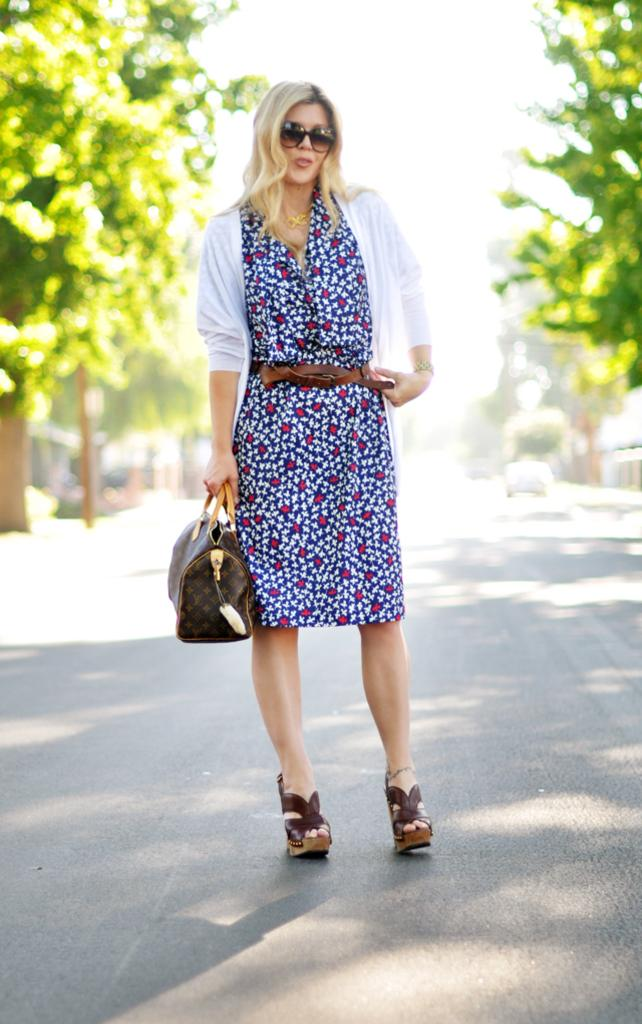Who is present in the image? There is a woman in the image. What is the woman holding in the image? The woman is holding a bag. What is the woman wearing in the image? The woman is wearing a vest. What is the color or style of the woman's hair in the image? The woman has blond hair. Where is the woman standing in the image? The woman is standing on a road. What can be seen on either side of the road in the image? There are trees on either side of the road. What else is visible in the image besides the woman? There is a car visible in the image. What type of flame can be seen coming from the woman's hair in the image? There is no flame present in the image; the woman has blond hair. What type of watch is the laborer wearing in the image? There is no laborer present in the image, and therefore no watch to describe. 